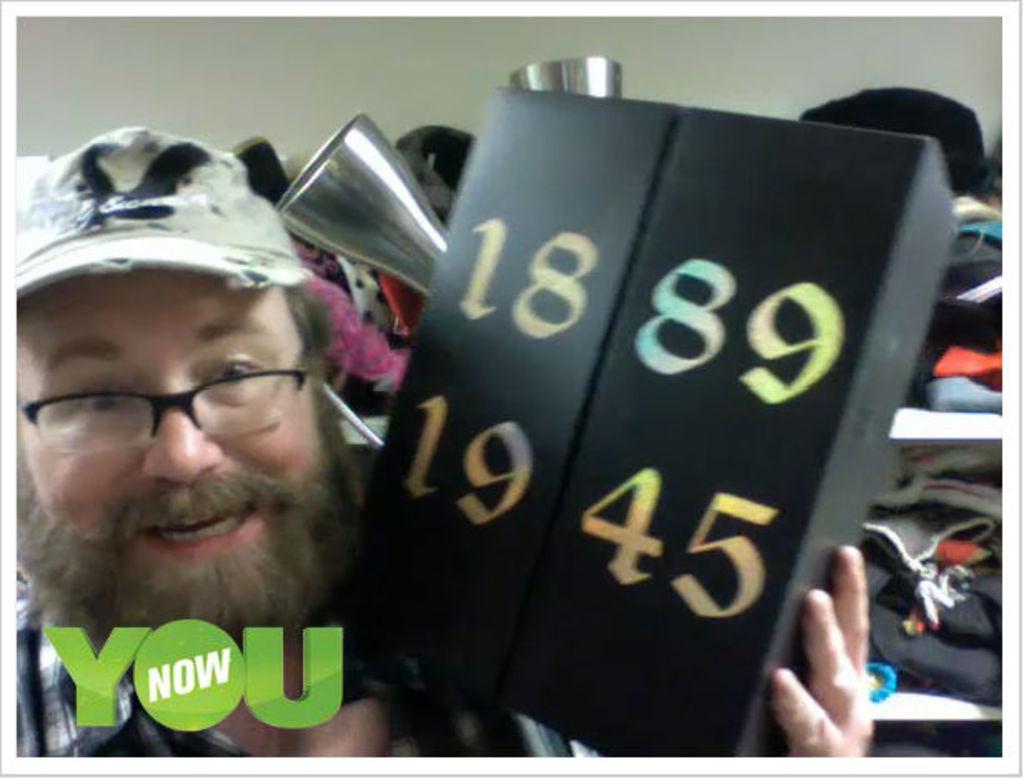Can you describe this image briefly? In this picture we can see a person wearing spectacles, he is holding a box, on which we can see some numbers, behind we can see some clothes in a shelves. 